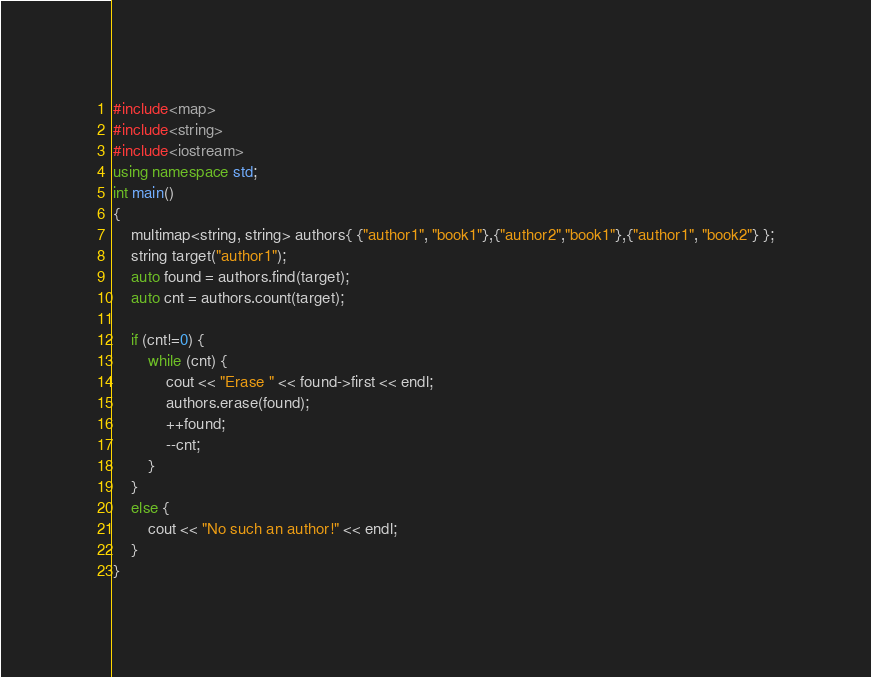<code> <loc_0><loc_0><loc_500><loc_500><_C++_>#include<map>
#include<string>
#include<iostream>
using namespace std;
int main()
{
	multimap<string, string> authors{ {"author1", "book1"},{"author2","book1"},{"author1", "book2"} };
	string target("author1");
	auto found = authors.find(target);
	auto cnt = authors.count(target);
	
	if (cnt!=0) {
		while (cnt) {
			cout << "Erase " << found->first << endl;
			authors.erase(found);
			++found;
			--cnt;
		}
	}
	else {
		cout << "No such an author!" << endl;
	}
}

</code> 